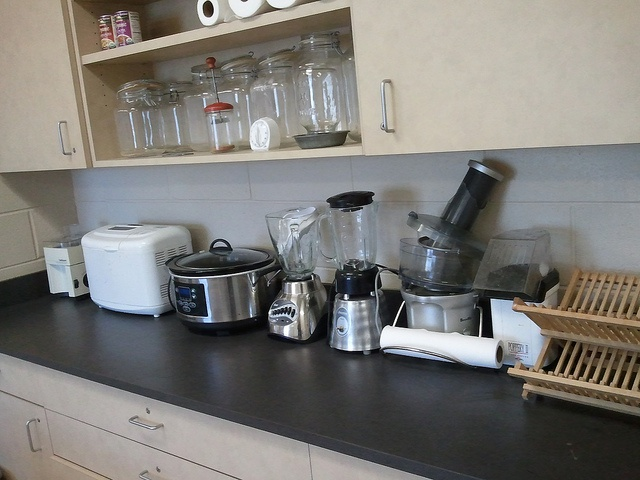Describe the objects in this image and their specific colors. I can see toaster in darkgray, lightgray, lightblue, and gray tones, bottle in darkgray, gray, and lightgray tones, bottle in darkgray, black, and gray tones, bottle in darkgray and gray tones, and bottle in darkgray, gray, and lightgray tones in this image. 